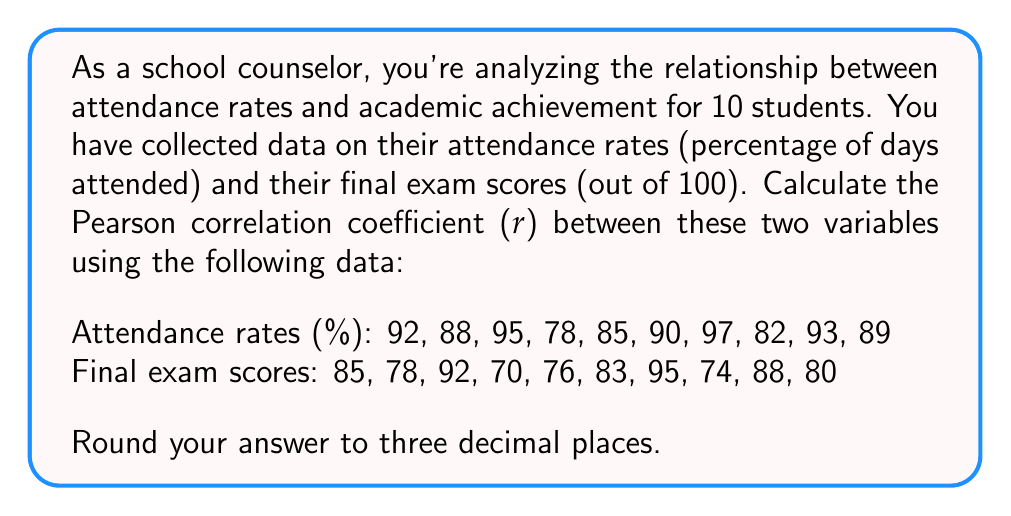Give your solution to this math problem. To calculate the Pearson correlation coefficient (r), we'll use the formula:

$$ r = \frac{n\sum xy - \sum x \sum y}{\sqrt{[n\sum x^2 - (\sum x)^2][n\sum y^2 - (\sum y)^2]}} $$

Where:
x = attendance rates
y = final exam scores
n = number of students (10)

Step 1: Calculate the sums and squares:
$\sum x = 889$
$\sum y = 821$
$\sum xy = 73,309$
$\sum x^2 = 79,373$
$\sum y^2 = 67,805$

Step 2: Substitute these values into the formula:

$$ r = \frac{10(73,309) - (889)(821)}{\sqrt{[10(79,373) - (889)^2][10(67,805) - (821)^2]}} $$

Step 3: Simplify:

$$ r = \frac{733,090 - 729,869}{\sqrt{(793,730 - 790,321)(678,050 - 674,041)}} $$

$$ r = \frac{3,221}{\sqrt{(3,409)(4,009)}} $$

$$ r = \frac{3,221}{\sqrt{13,666,681}} $$

$$ r = \frac{3,221}{3,696.85} $$

$$ r \approx 0.871 $$

This strong positive correlation indicates that there is a significant relationship between attendance rates and academic achievement, supporting the importance of individualized learning plans that address attendance issues.
Answer: 0.871 